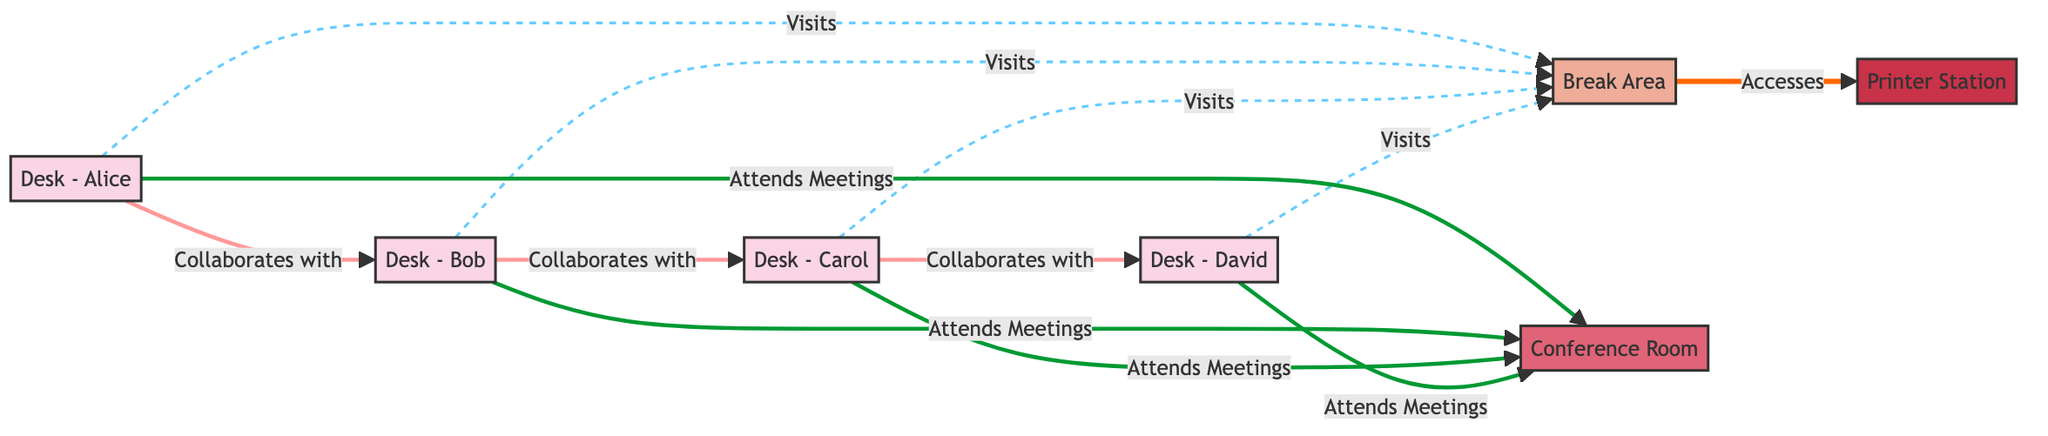What are the nodes in the diagram? The nodes include: Desk - Alice, Desk - Bob, Desk - Carol, Desk - David, Break Area, Conference Room, and Printer Station.
Answer: Desk - Alice, Desk - Bob, Desk - Carol, Desk - David, Break Area, Conference Room, Printer Station How many desks are in the diagram? There are four desks visible in the diagram: Desk - Alice, Desk - Bob, Desk - Carol, and Desk - David.
Answer: 4 Which desk collaborates with Desk - Bob? According to the diagram, Desk - Alice collaborates with Desk - Bob.
Answer: Desk - Alice How many users are linked to the Break Area? The diagram shows that all four desks (Desk - Alice, Desk - Bob, Desk - Carol, and Desk - David) have links to the Break Area, representing visits. This gives us a total of four links.
Answer: 4 What is the relationship between the Break Area and the Printer Station? The diagram specifies that the Break Area accesses the Printer Station, establishing a direct connection between the two.
Answer: Accesses Which desks attend meetings in the Conference Room? All four desks: Desk - Alice, Desk - Bob, Desk - Carol, and Desk - David attend meetings in the Conference Room, as indicated by the connections.
Answer: Desk - Alice, Desk - Bob, Desk - Carol, Desk - David Which is the only station accessed from the Break Area? The data shows that the only station accessed from the Break Area is the Printer Station.
Answer: Printer Station What type of connection exists between Desk - Carol and Desk - David? The connection between Desk - Carol and Desk - David is labeled as "Collaborates with", indicating a collaborative relationship.
Answer: Collaborates with How many collaboration relationships are shown in the diagram? The diagram illustrates three direct collaboration relationships among the desks: between Desk - Alice and Desk - Bob, Desk - Bob and Desk - Carol, and Desk - Carol and Desk - David.
Answer: 3 